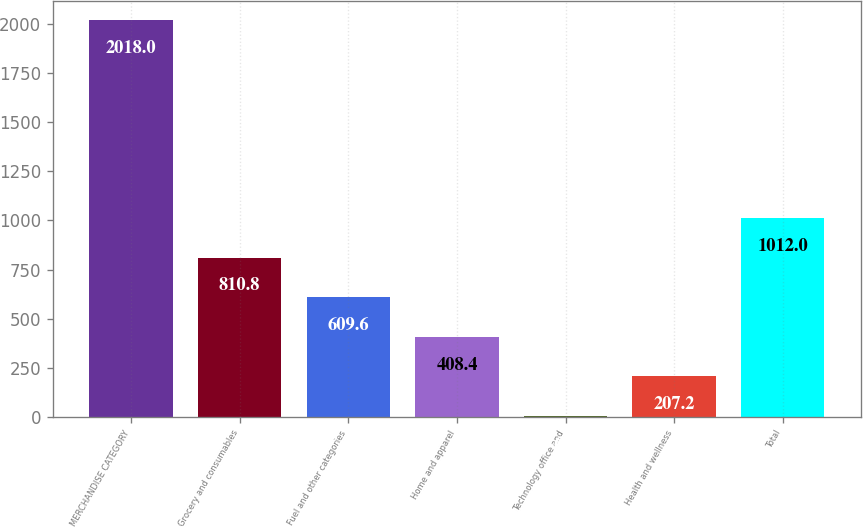Convert chart to OTSL. <chart><loc_0><loc_0><loc_500><loc_500><bar_chart><fcel>MERCHANDISE CATEGORY<fcel>Grocery and consumables<fcel>Fuel and other categories<fcel>Home and apparel<fcel>Technology office and<fcel>Health and wellness<fcel>Total<nl><fcel>2018<fcel>810.8<fcel>609.6<fcel>408.4<fcel>6<fcel>207.2<fcel>1012<nl></chart> 